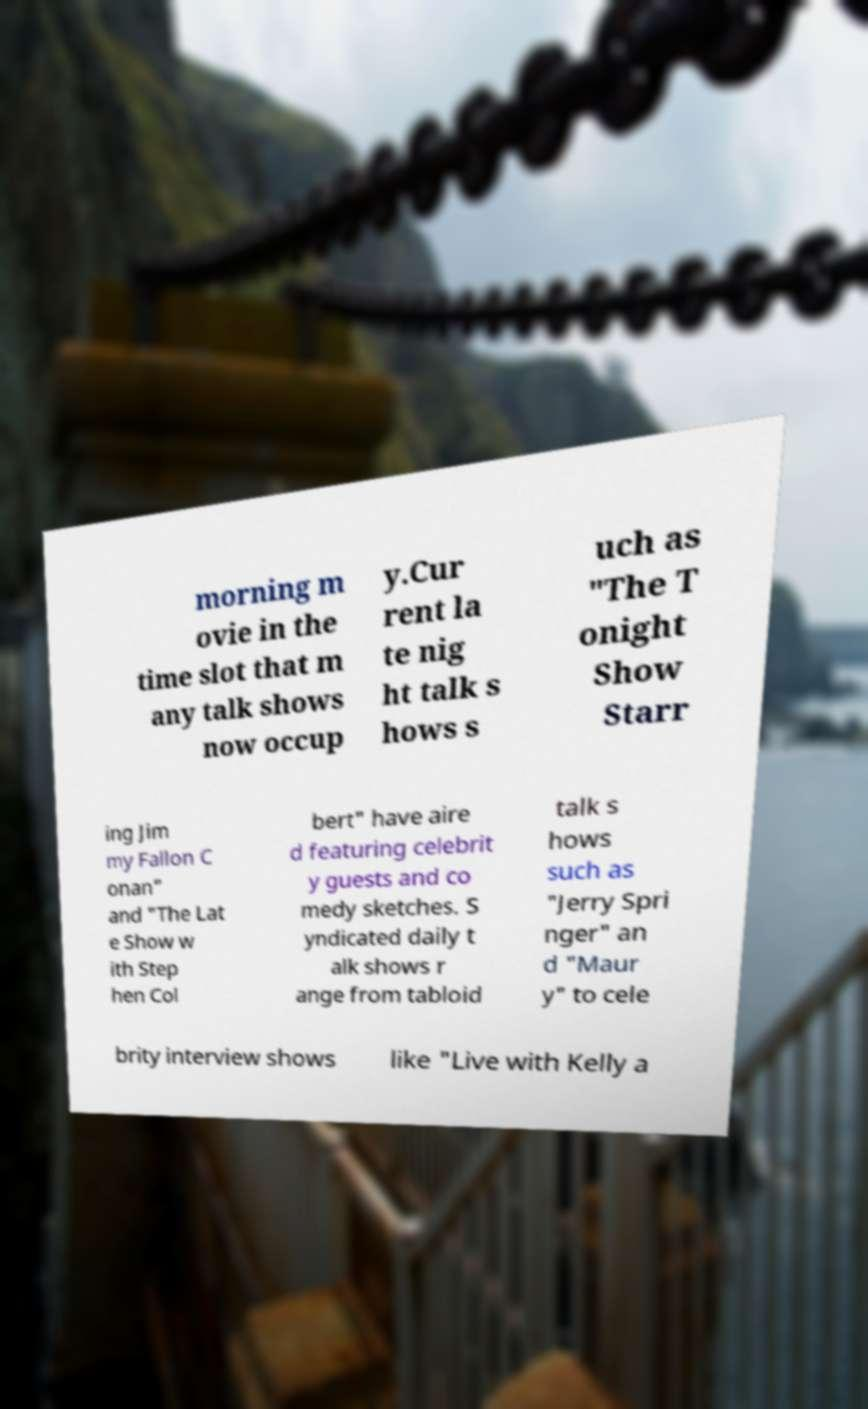What messages or text are displayed in this image? I need them in a readable, typed format. morning m ovie in the time slot that m any talk shows now occup y.Cur rent la te nig ht talk s hows s uch as "The T onight Show Starr ing Jim my Fallon C onan" and "The Lat e Show w ith Step hen Col bert" have aire d featuring celebrit y guests and co medy sketches. S yndicated daily t alk shows r ange from tabloid talk s hows such as "Jerry Spri nger" an d "Maur y" to cele brity interview shows like "Live with Kelly a 